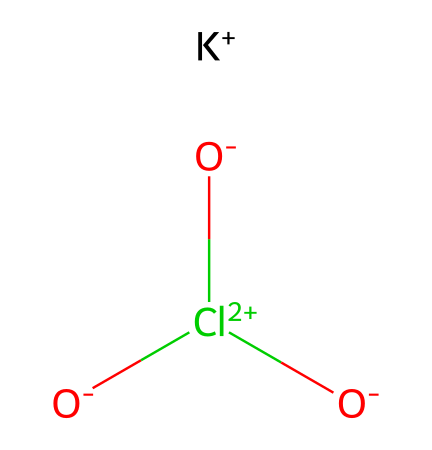What is the molecular formula of potassium chlorate? The SMILES representation indicates the presence of potassium (K), chlorine (Cl), and oxygen (O) atoms. By counting these atoms, we can derive the molecular formula, which is KClO3.
Answer: KClO3 How many oxygen atoms are present in potassium chlorate? Analyzing the SMILES representation, the "O" appears three times, indicating there are three oxygen atoms associated with potassium chlorate.
Answer: 3 What charge does the potassium ion have in this compound? The SMILES representation shows "[K+]," which indicates that the potassium ion has a positive charge.
Answer: +1 Is potassium chlorate considered an oxidizer? Potassium chlorate is known for its ability to release oxygen upon thermal decomposition, making it a strong oxidizer in chemical reactions.
Answer: yes What is the oxidation state of chlorine in potassium chlorate? In the structure, chlorine is bonded to three oxygen atoms, each likely carrying a -2 oxidation state. The overall charge of the ion helps calculate that chlorine must have an oxidation state of +5 to balance the -6 from the oxygens.
Answer: +5 What role does potassium chlorate play in the ignition of matches? Potassium chlorate decomposes to release oxygen, which helps to ignite the fuel material in the match when struck. The release of oxygen enhances combustion, making it an essential component in matches.
Answer: combustion enhancer How many total atoms are in one molecule of potassium chlorate? The molecular structure consists of 1 potassium atom, 1 chlorine atom, and 3 oxygen atoms. Therefore, the total count is 1 + 1 + 3 = 5 atoms in the molecule.
Answer: 5 